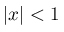Convert formula to latex. <formula><loc_0><loc_0><loc_500><loc_500>| x | < 1</formula> 